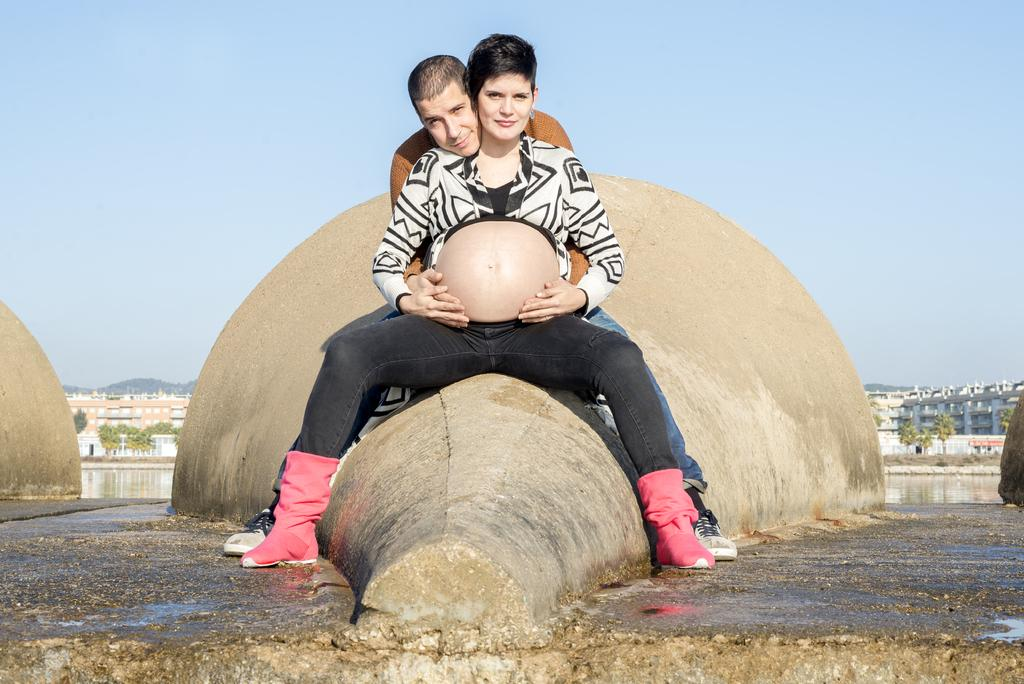What is the woman in the image doing? The woman is sitting in the image. What is the woman wearing on her lower body? The woman is wearing black color trousers. Can you describe the person behind the woman? There is a man behind the woman in the image. What is the weather like in the image? The sky is visible at the top of the image, and it is sunny, indicating a clear and bright day. What type of nut is being used as a cannonball in the image? There is no cannon or nut present in the image. Where is the cellar located in the image? There is no mention of a cellar in the image; it only features a woman sitting and a man behind her. 